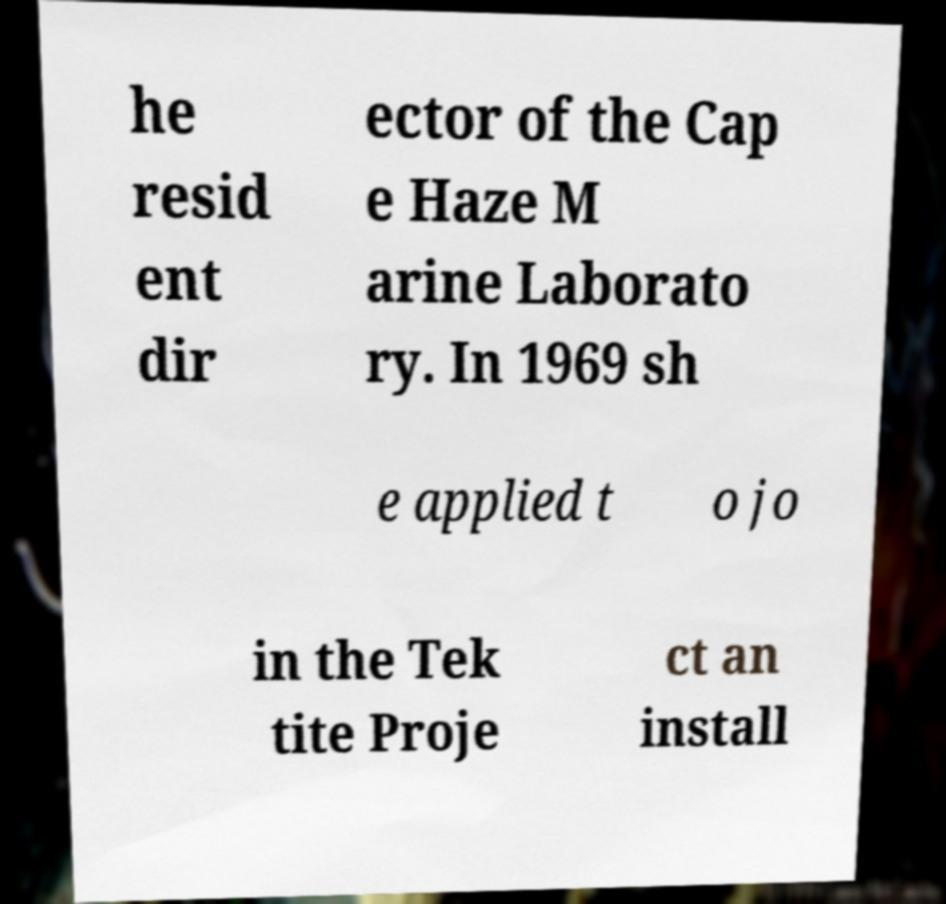For documentation purposes, I need the text within this image transcribed. Could you provide that? he resid ent dir ector of the Cap e Haze M arine Laborato ry. In 1969 sh e applied t o jo in the Tek tite Proje ct an install 